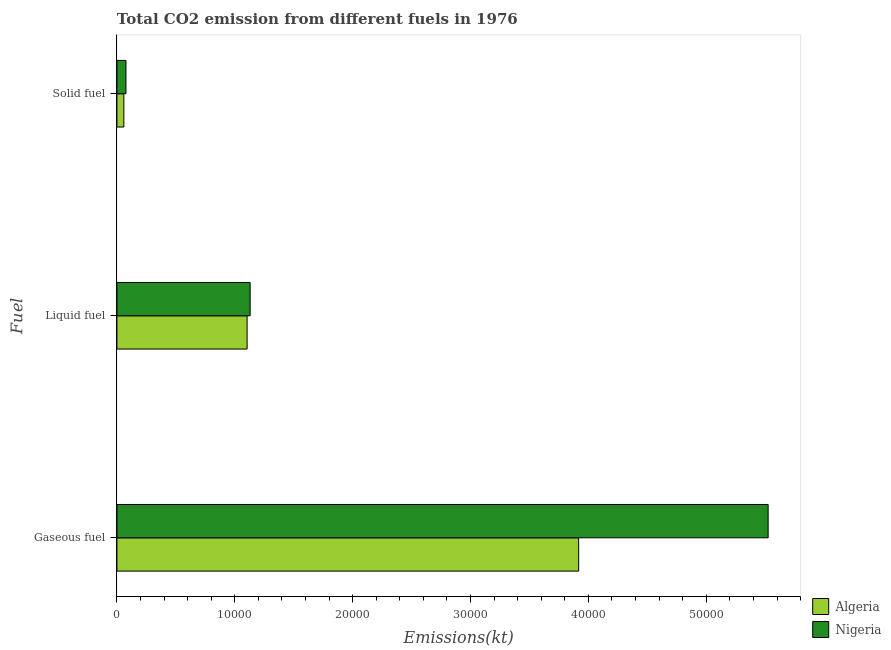How many different coloured bars are there?
Provide a short and direct response. 2. How many groups of bars are there?
Your answer should be compact. 3. Are the number of bars per tick equal to the number of legend labels?
Your response must be concise. Yes. Are the number of bars on each tick of the Y-axis equal?
Your answer should be compact. Yes. How many bars are there on the 3rd tick from the bottom?
Offer a terse response. 2. What is the label of the 2nd group of bars from the top?
Your answer should be compact. Liquid fuel. What is the amount of co2 emissions from liquid fuel in Algeria?
Offer a terse response. 1.10e+04. Across all countries, what is the maximum amount of co2 emissions from liquid fuel?
Your answer should be compact. 1.13e+04. Across all countries, what is the minimum amount of co2 emissions from solid fuel?
Offer a terse response. 586.72. In which country was the amount of co2 emissions from liquid fuel maximum?
Keep it short and to the point. Nigeria. In which country was the amount of co2 emissions from gaseous fuel minimum?
Ensure brevity in your answer.  Algeria. What is the total amount of co2 emissions from gaseous fuel in the graph?
Ensure brevity in your answer.  9.44e+04. What is the difference between the amount of co2 emissions from gaseous fuel in Nigeria and that in Algeria?
Make the answer very short. 1.61e+04. What is the difference between the amount of co2 emissions from solid fuel in Algeria and the amount of co2 emissions from liquid fuel in Nigeria?
Give a very brief answer. -1.07e+04. What is the average amount of co2 emissions from solid fuel per country?
Offer a very short reply. 676.56. What is the difference between the amount of co2 emissions from gaseous fuel and amount of co2 emissions from solid fuel in Algeria?
Make the answer very short. 3.86e+04. In how many countries, is the amount of co2 emissions from solid fuel greater than 14000 kt?
Your answer should be very brief. 0. What is the ratio of the amount of co2 emissions from liquid fuel in Algeria to that in Nigeria?
Your answer should be very brief. 0.98. Is the amount of co2 emissions from gaseous fuel in Algeria less than that in Nigeria?
Your response must be concise. Yes. Is the difference between the amount of co2 emissions from gaseous fuel in Nigeria and Algeria greater than the difference between the amount of co2 emissions from solid fuel in Nigeria and Algeria?
Offer a very short reply. Yes. What is the difference between the highest and the second highest amount of co2 emissions from gaseous fuel?
Your answer should be compact. 1.61e+04. What is the difference between the highest and the lowest amount of co2 emissions from liquid fuel?
Ensure brevity in your answer.  256.69. In how many countries, is the amount of co2 emissions from gaseous fuel greater than the average amount of co2 emissions from gaseous fuel taken over all countries?
Offer a very short reply. 1. What does the 2nd bar from the top in Gaseous fuel represents?
Provide a succinct answer. Algeria. What does the 1st bar from the bottom in Gaseous fuel represents?
Offer a terse response. Algeria. Are all the bars in the graph horizontal?
Offer a terse response. Yes. What is the difference between two consecutive major ticks on the X-axis?
Offer a terse response. 10000. Are the values on the major ticks of X-axis written in scientific E-notation?
Ensure brevity in your answer.  No. Does the graph contain any zero values?
Offer a very short reply. No. How many legend labels are there?
Offer a very short reply. 2. What is the title of the graph?
Offer a terse response. Total CO2 emission from different fuels in 1976. What is the label or title of the X-axis?
Provide a short and direct response. Emissions(kt). What is the label or title of the Y-axis?
Offer a very short reply. Fuel. What is the Emissions(kt) in Algeria in Gaseous fuel?
Offer a terse response. 3.92e+04. What is the Emissions(kt) of Nigeria in Gaseous fuel?
Your answer should be very brief. 5.52e+04. What is the Emissions(kt) of Algeria in Liquid fuel?
Offer a very short reply. 1.10e+04. What is the Emissions(kt) of Nigeria in Liquid fuel?
Keep it short and to the point. 1.13e+04. What is the Emissions(kt) in Algeria in Solid fuel?
Provide a succinct answer. 586.72. What is the Emissions(kt) of Nigeria in Solid fuel?
Offer a very short reply. 766.4. Across all Fuel, what is the maximum Emissions(kt) in Algeria?
Give a very brief answer. 3.92e+04. Across all Fuel, what is the maximum Emissions(kt) of Nigeria?
Keep it short and to the point. 5.52e+04. Across all Fuel, what is the minimum Emissions(kt) in Algeria?
Ensure brevity in your answer.  586.72. Across all Fuel, what is the minimum Emissions(kt) in Nigeria?
Ensure brevity in your answer.  766.4. What is the total Emissions(kt) in Algeria in the graph?
Make the answer very short. 5.08e+04. What is the total Emissions(kt) of Nigeria in the graph?
Your response must be concise. 6.73e+04. What is the difference between the Emissions(kt) in Algeria in Gaseous fuel and that in Liquid fuel?
Give a very brief answer. 2.81e+04. What is the difference between the Emissions(kt) in Nigeria in Gaseous fuel and that in Liquid fuel?
Your answer should be very brief. 4.39e+04. What is the difference between the Emissions(kt) of Algeria in Gaseous fuel and that in Solid fuel?
Keep it short and to the point. 3.86e+04. What is the difference between the Emissions(kt) of Nigeria in Gaseous fuel and that in Solid fuel?
Provide a short and direct response. 5.45e+04. What is the difference between the Emissions(kt) in Algeria in Liquid fuel and that in Solid fuel?
Your response must be concise. 1.05e+04. What is the difference between the Emissions(kt) in Nigeria in Liquid fuel and that in Solid fuel?
Your answer should be very brief. 1.05e+04. What is the difference between the Emissions(kt) in Algeria in Gaseous fuel and the Emissions(kt) in Nigeria in Liquid fuel?
Offer a terse response. 2.79e+04. What is the difference between the Emissions(kt) of Algeria in Gaseous fuel and the Emissions(kt) of Nigeria in Solid fuel?
Make the answer very short. 3.84e+04. What is the difference between the Emissions(kt) in Algeria in Liquid fuel and the Emissions(kt) in Nigeria in Solid fuel?
Provide a succinct answer. 1.03e+04. What is the average Emissions(kt) of Algeria per Fuel?
Offer a very short reply. 1.69e+04. What is the average Emissions(kt) in Nigeria per Fuel?
Offer a very short reply. 2.24e+04. What is the difference between the Emissions(kt) in Algeria and Emissions(kt) in Nigeria in Gaseous fuel?
Provide a succinct answer. -1.61e+04. What is the difference between the Emissions(kt) of Algeria and Emissions(kt) of Nigeria in Liquid fuel?
Offer a very short reply. -256.69. What is the difference between the Emissions(kt) in Algeria and Emissions(kt) in Nigeria in Solid fuel?
Ensure brevity in your answer.  -179.68. What is the ratio of the Emissions(kt) in Algeria in Gaseous fuel to that in Liquid fuel?
Provide a short and direct response. 3.55. What is the ratio of the Emissions(kt) in Nigeria in Gaseous fuel to that in Liquid fuel?
Offer a terse response. 4.89. What is the ratio of the Emissions(kt) of Algeria in Gaseous fuel to that in Solid fuel?
Your response must be concise. 66.76. What is the ratio of the Emissions(kt) in Nigeria in Gaseous fuel to that in Solid fuel?
Offer a very short reply. 72.09. What is the ratio of the Emissions(kt) in Algeria in Liquid fuel to that in Solid fuel?
Offer a terse response. 18.82. What is the ratio of the Emissions(kt) in Nigeria in Liquid fuel to that in Solid fuel?
Offer a terse response. 14.75. What is the difference between the highest and the second highest Emissions(kt) of Algeria?
Keep it short and to the point. 2.81e+04. What is the difference between the highest and the second highest Emissions(kt) of Nigeria?
Make the answer very short. 4.39e+04. What is the difference between the highest and the lowest Emissions(kt) of Algeria?
Your response must be concise. 3.86e+04. What is the difference between the highest and the lowest Emissions(kt) in Nigeria?
Provide a short and direct response. 5.45e+04. 